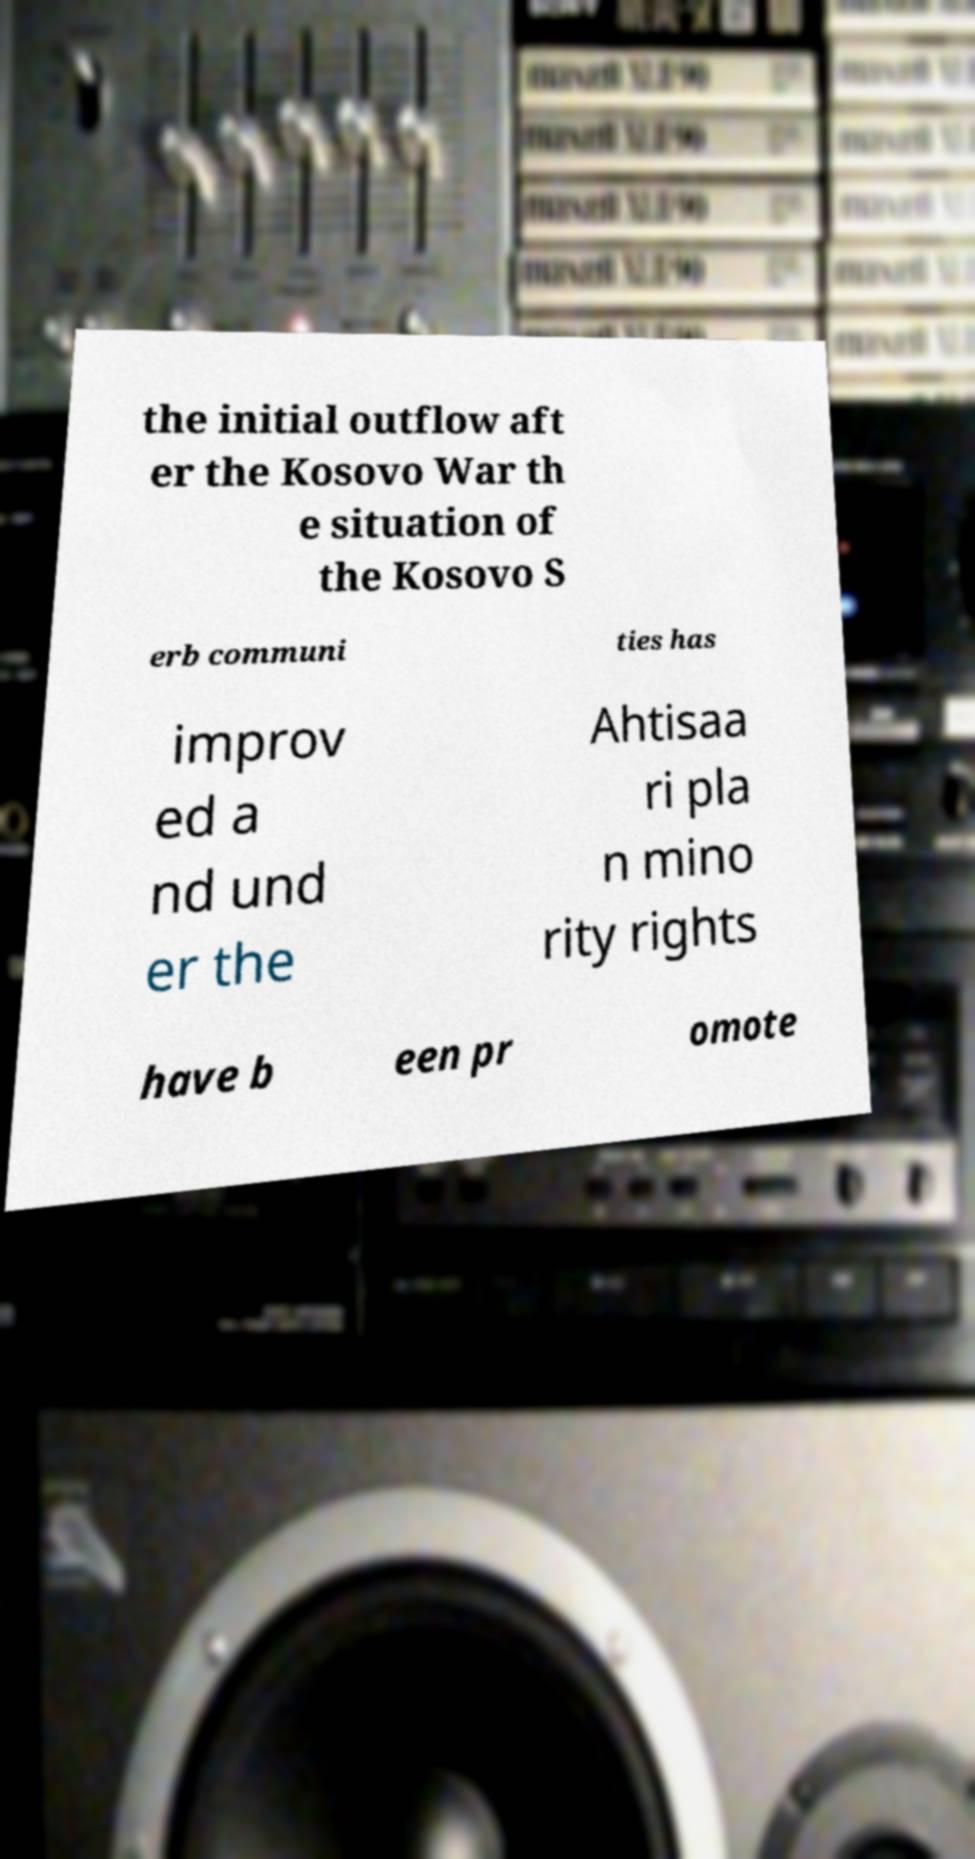What messages or text are displayed in this image? I need them in a readable, typed format. the initial outflow aft er the Kosovo War th e situation of the Kosovo S erb communi ties has improv ed a nd und er the Ahtisaa ri pla n mino rity rights have b een pr omote 